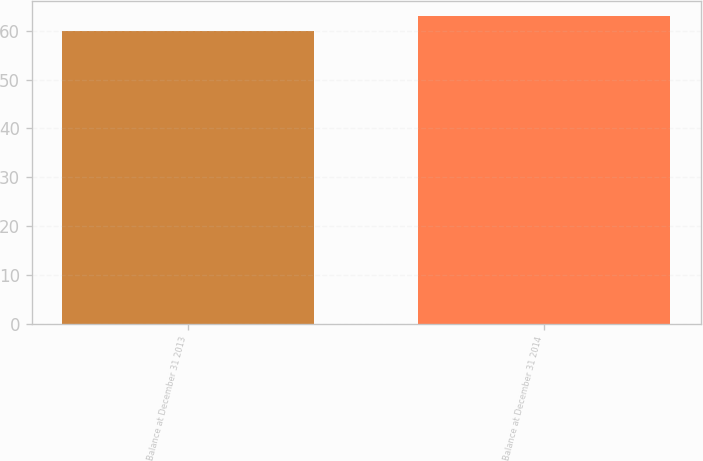Convert chart. <chart><loc_0><loc_0><loc_500><loc_500><bar_chart><fcel>Balance at December 31 2013<fcel>Balance at December 31 2014<nl><fcel>60<fcel>63<nl></chart> 